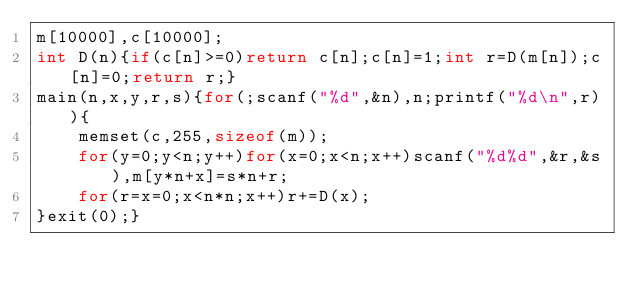<code> <loc_0><loc_0><loc_500><loc_500><_C_>m[10000],c[10000];
int D(n){if(c[n]>=0)return c[n];c[n]=1;int r=D(m[n]);c[n]=0;return r;}
main(n,x,y,r,s){for(;scanf("%d",&n),n;printf("%d\n",r)){
	memset(c,255,sizeof(m));
	for(y=0;y<n;y++)for(x=0;x<n;x++)scanf("%d%d",&r,&s),m[y*n+x]=s*n+r;
	for(r=x=0;x<n*n;x++)r+=D(x);
}exit(0);}</code> 